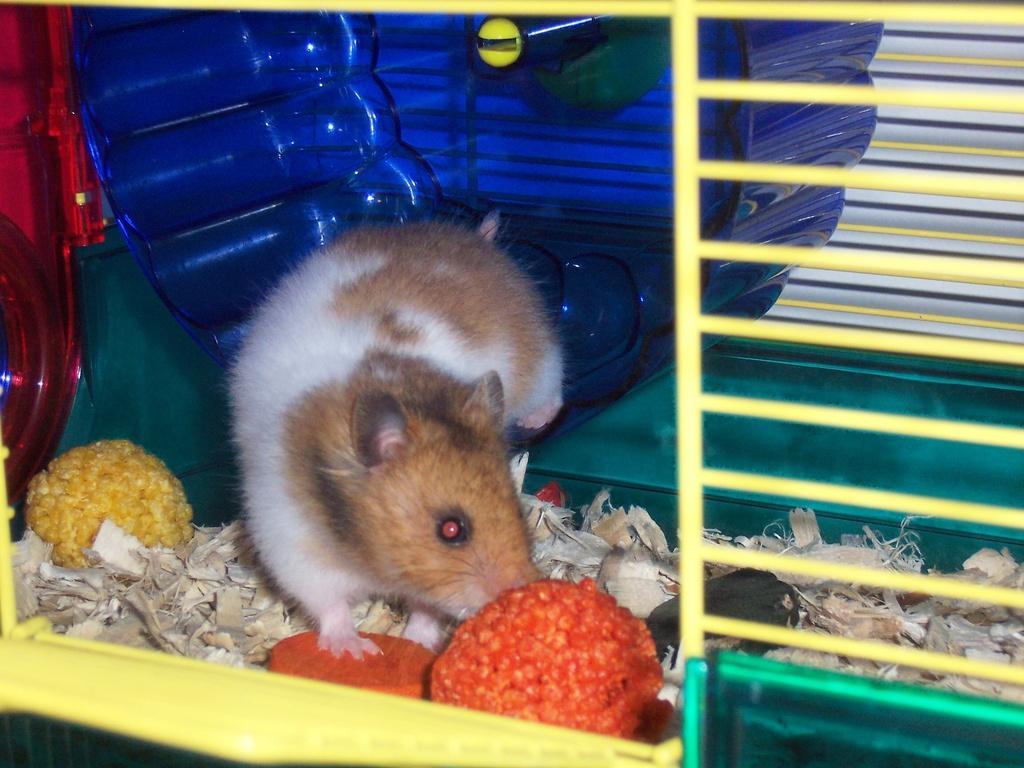In one or two sentences, can you explain what this image depicts? In this image I can see a rat in cage with some food items and wood pieces. And at the background there is an object. 